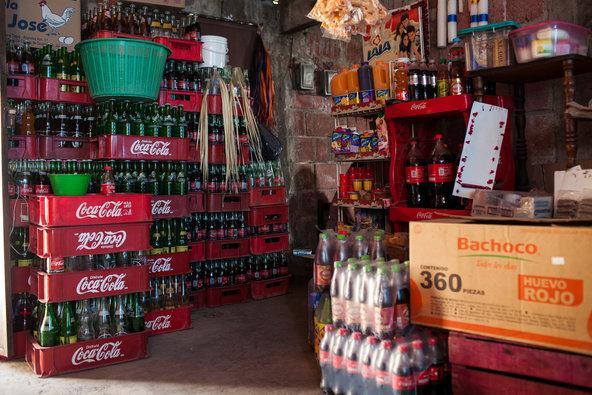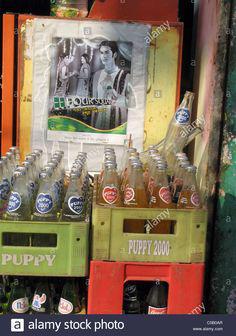The first image is the image on the left, the second image is the image on the right. For the images shown, is this caption "Some of the soda bottles are in plastic crates." true? Answer yes or no. Yes. The first image is the image on the left, the second image is the image on the right. For the images displayed, is the sentence "All the bottles are full." factually correct? Answer yes or no. No. 